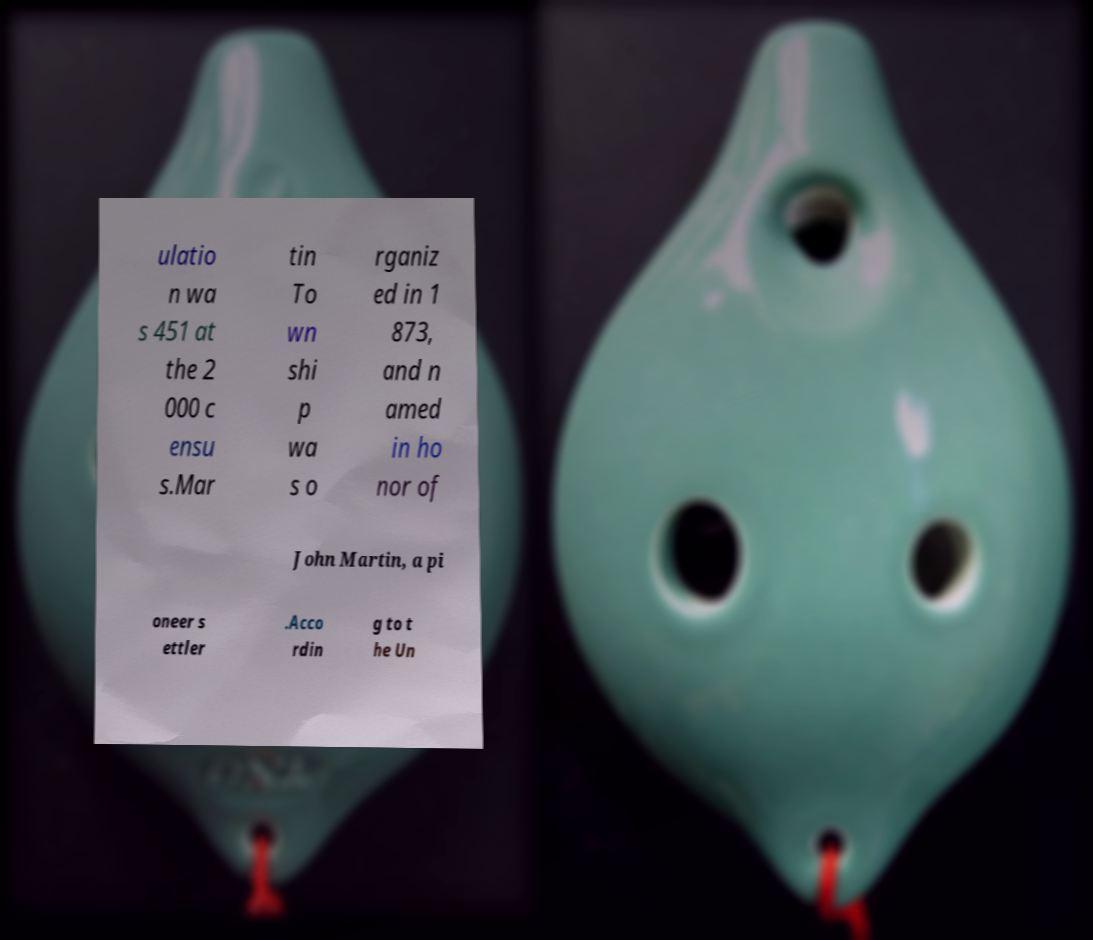For documentation purposes, I need the text within this image transcribed. Could you provide that? ulatio n wa s 451 at the 2 000 c ensu s.Mar tin To wn shi p wa s o rganiz ed in 1 873, and n amed in ho nor of John Martin, a pi oneer s ettler .Acco rdin g to t he Un 